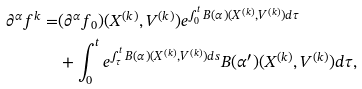<formula> <loc_0><loc_0><loc_500><loc_500>\partial ^ { \alpha } f ^ { k } = & ( \partial ^ { \alpha } f _ { 0 } ) ( X ^ { ( k ) } , V ^ { ( k ) } ) e ^ { \int _ { 0 } ^ { t } B ( \alpha ) ( X ^ { ( k ) } , V ^ { ( k ) } ) d \tau } \\ & + \int _ { 0 } ^ { t } e ^ { \int _ { \tau } ^ { t } B ( \alpha ) ( X ^ { ( k ) } , V ^ { ( k ) } ) d s } B ( \alpha ^ { \prime } ) ( X ^ { ( k ) } , V ^ { ( k ) } ) d \tau ,</formula> 